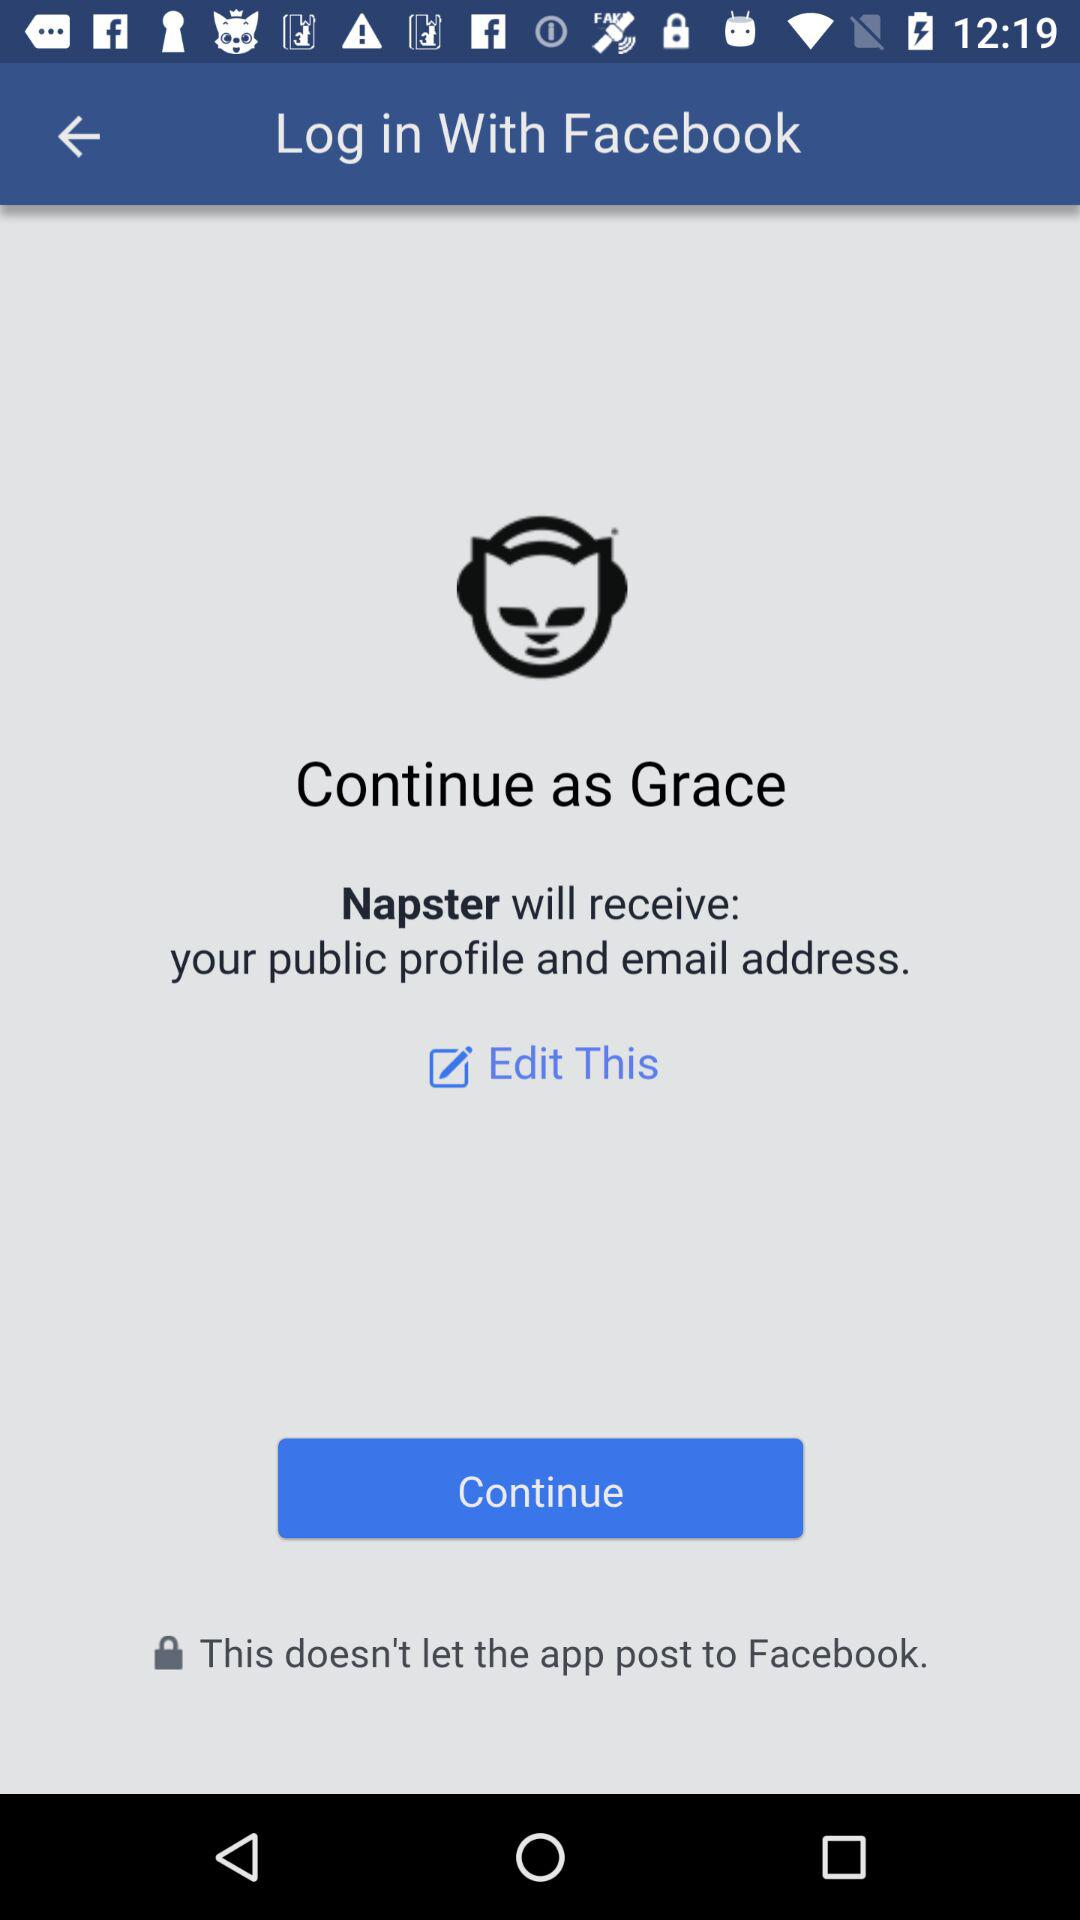What's Grace's surname?
When the provided information is insufficient, respond with <no answer>. <no answer> 